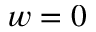<formula> <loc_0><loc_0><loc_500><loc_500>w = 0</formula> 